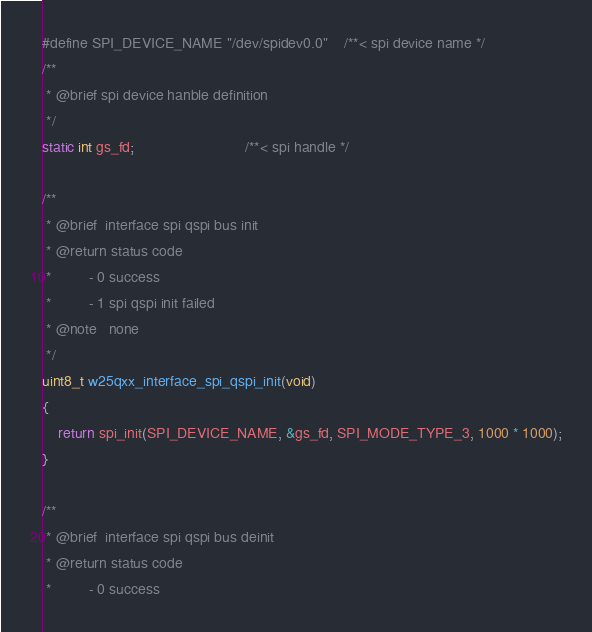Convert code to text. <code><loc_0><loc_0><loc_500><loc_500><_C_>#define SPI_DEVICE_NAME "/dev/spidev0.0"    /**< spi device name */
/**
 * @brief spi device hanble definition
 */
static int gs_fd;                           /**< spi handle */

/**
 * @brief  interface spi qspi bus init
 * @return status code
 *         - 0 success
 *         - 1 spi qspi init failed
 * @note   none
 */
uint8_t w25qxx_interface_spi_qspi_init(void)
{
    return spi_init(SPI_DEVICE_NAME, &gs_fd, SPI_MODE_TYPE_3, 1000 * 1000);
}

/**
 * @brief  interface spi qspi bus deinit
 * @return status code
 *         - 0 success</code> 